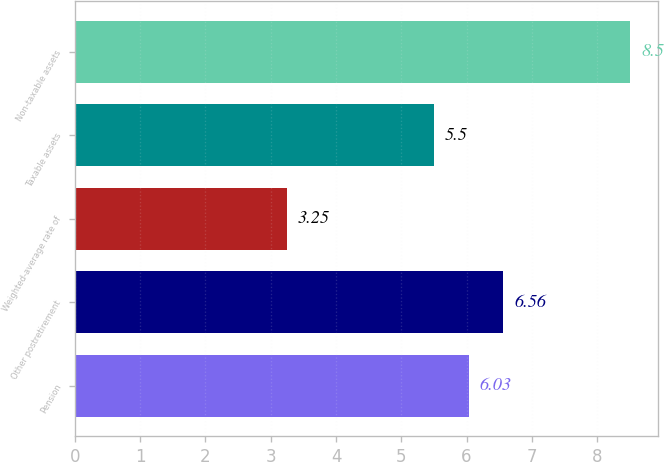Convert chart to OTSL. <chart><loc_0><loc_0><loc_500><loc_500><bar_chart><fcel>Pension<fcel>Other postretirement<fcel>Weighted-average rate of<fcel>Taxable assets<fcel>Non-taxable assets<nl><fcel>6.03<fcel>6.56<fcel>3.25<fcel>5.5<fcel>8.5<nl></chart> 